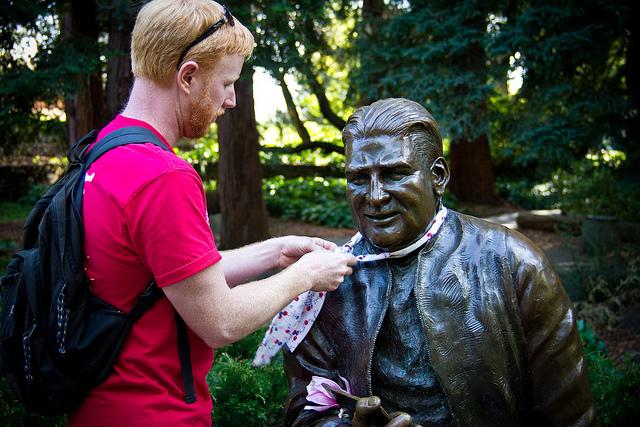How many living people are in this image?
Give a very brief answer. 1. What does the man have on top of his head?
Give a very brief answer. Sunglasses. What is the man tying around the statues neck?
Concise answer only. Tie. 